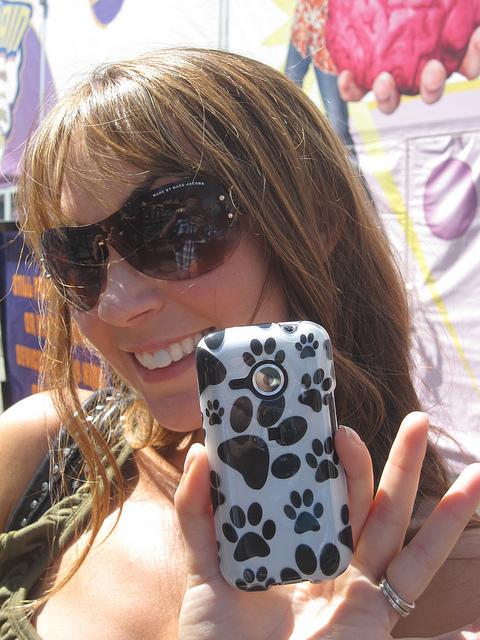What is on her head?
Keep it brief. Sunglasses. What color is the woman's top?
Concise answer only. Green. Is this person's phone small?
Answer briefly. Yes. What is the design on her phone?
Give a very brief answer. Paw prints. Is the woman wearing a ring?
Write a very short answer. Yes. 